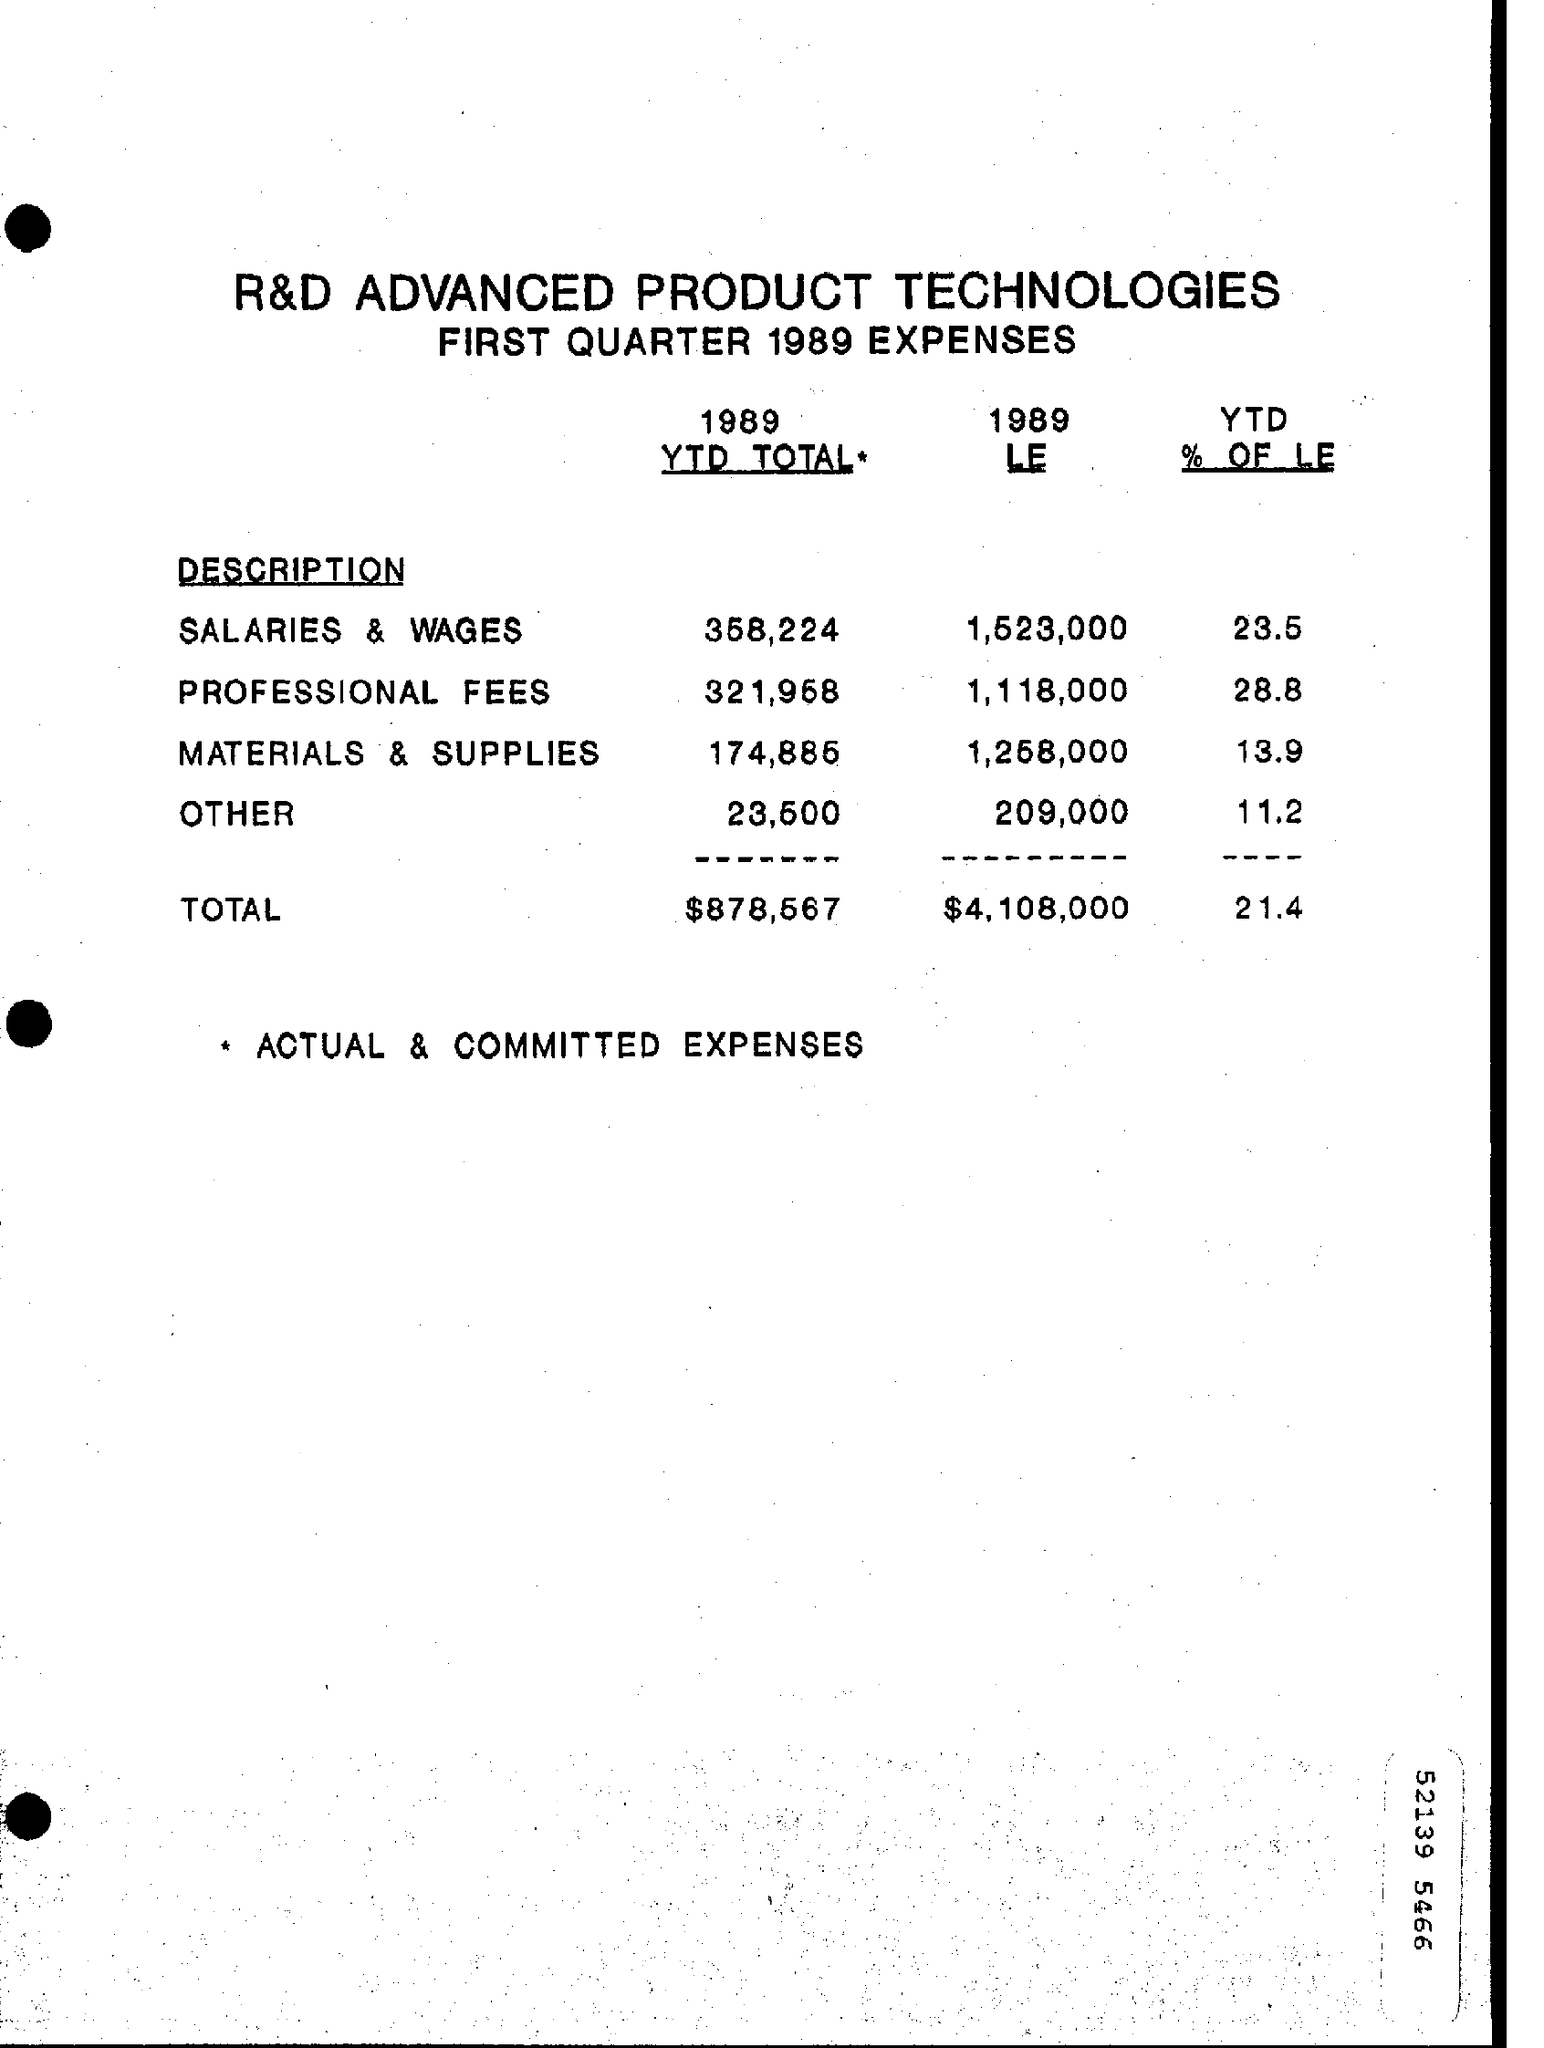Mention a couple of crucial points in this snapshot. The \* symbol represents actual and committed expenses. In the "1989 LE," the "Description" head with the highest expense is "Salaries & Wages. The "Description" head that has the lowest expense in the 1989 LE is the Other head. The total "YTD % of LE" is 21.4% as of now. The question asks for the highest percentage value in the "YTD % OF LE" column. 